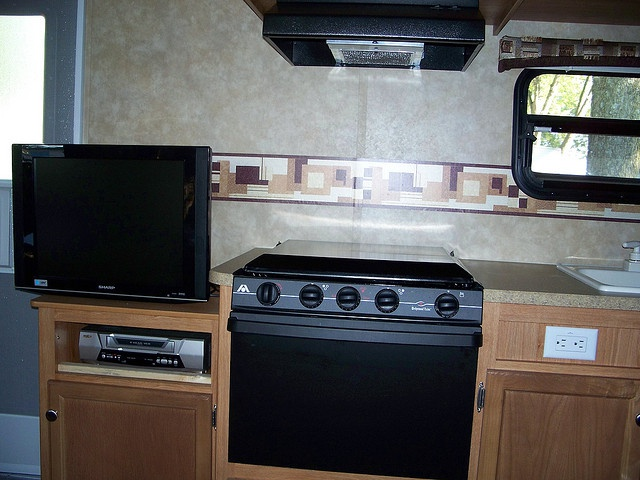Describe the objects in this image and their specific colors. I can see oven in black, gray, and darkgray tones, tv in black, gray, and blue tones, and sink in black, darkgray, and gray tones in this image. 